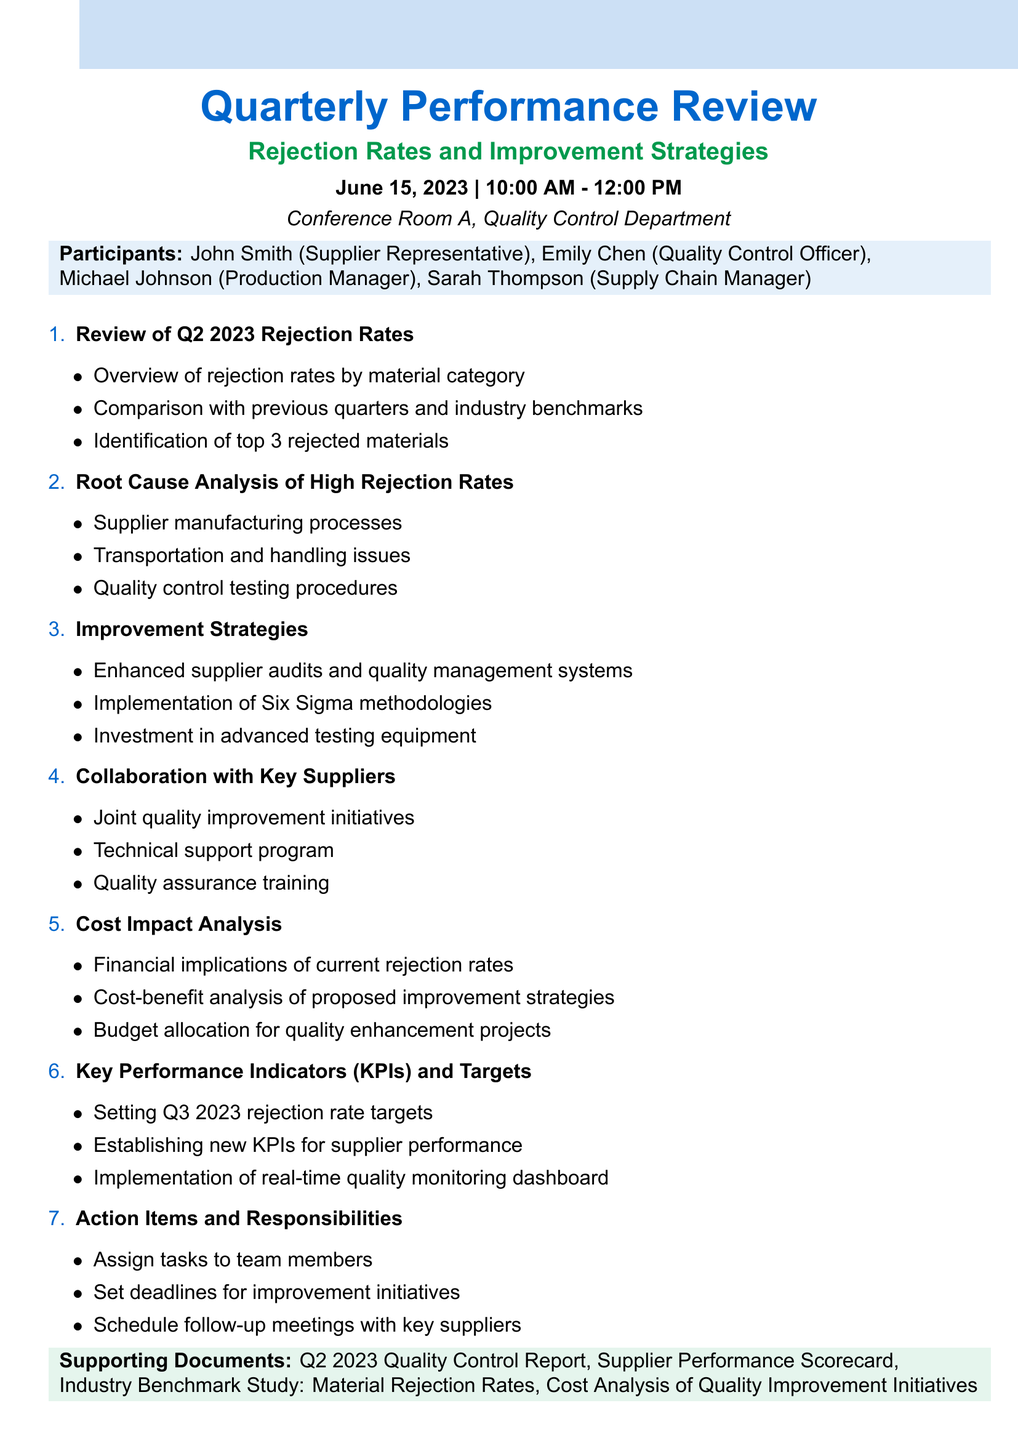What is the date of the quarterly performance review? The date is explicitly stated in the document as June 15, 2023.
Answer: June 15, 2023 Who is the Quality Control Officer? The document lists Emily Chen as the Quality Control Officer among the participants.
Answer: Emily Chen What is the location of the meeting? The location of the meeting is mentioned as the Conference Room A, Quality Control Department.
Answer: Conference Room A, Quality Control Department What are the top 3 rejected materials identified? The document specifies the top 3 rejected materials: PVC piping, aluminum sheets, and electronic components.
Answer: PVC piping, aluminum sheets, electronic components What methodology is proposed for improvement strategies? The agenda includes the Implementation of Six Sigma methodologies as a proposed improvement strategy.
Answer: Six Sigma methodologies What financial aspect is discussed concerning rejection rates? The agenda item on Cost Impact Analysis addresses the financial implications of current rejection rates.
Answer: Financial implications What is the purpose of the Joint quality improvement initiatives? This initiative aims to enhance collaboration with Acme Plastics, the PVC supplier, for quality improvement as stated in the document.
Answer: Quality improvement When is the follow-up meeting scheduled? The follow-up meetings are scheduled as action items towards the end of the agenda, but no specific date is provided in this document.
Answer: Not specified 